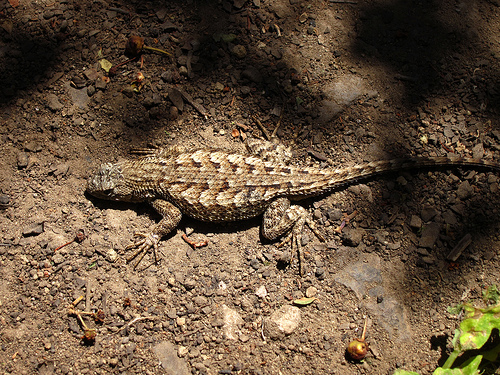<image>
Can you confirm if the rock is in front of the leaves? No. The rock is not in front of the leaves. The spatial positioning shows a different relationship between these objects. 